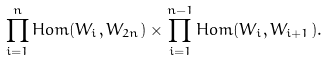<formula> <loc_0><loc_0><loc_500><loc_500>\prod _ { i = 1 } ^ { n } H o m ( W _ { i } , W _ { 2 n } ) \times \prod _ { i = 1 } ^ { n - 1 } H o m ( W _ { i } , W _ { i + 1 } ) .</formula> 